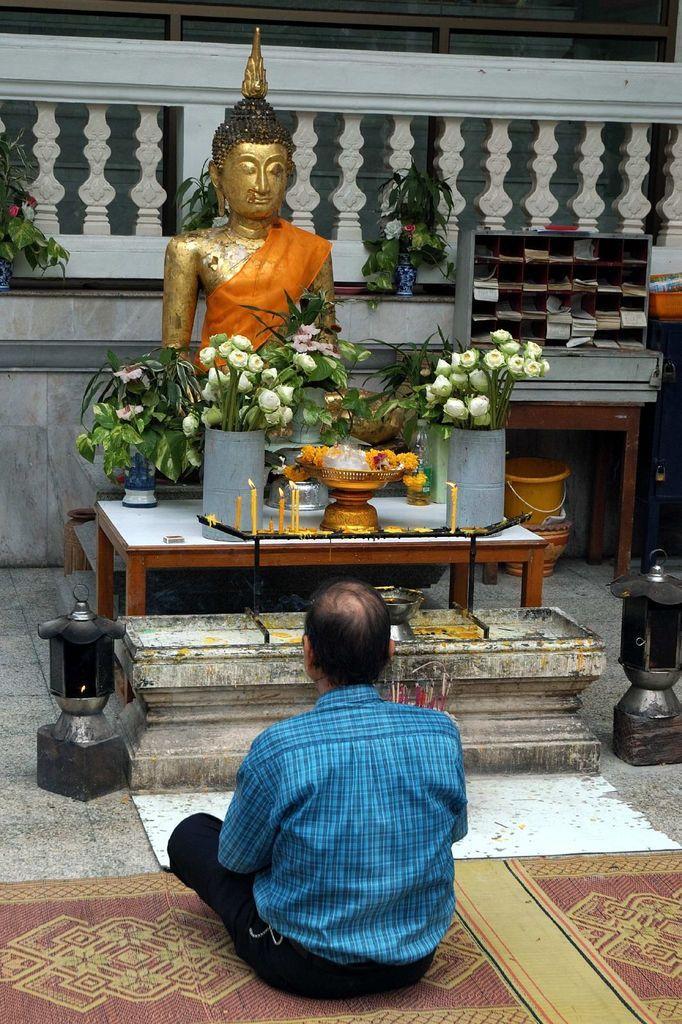Describe this image in one or two sentences. In the center we can see man sitting on floor. And here we can see statue in front we can see table,on table we can see candles,flowers and few more objects. And coming to background we can see shelf,bracket,wall,plant etc. 